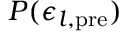Convert formula to latex. <formula><loc_0><loc_0><loc_500><loc_500>P ( \epsilon _ { l , p r e } )</formula> 